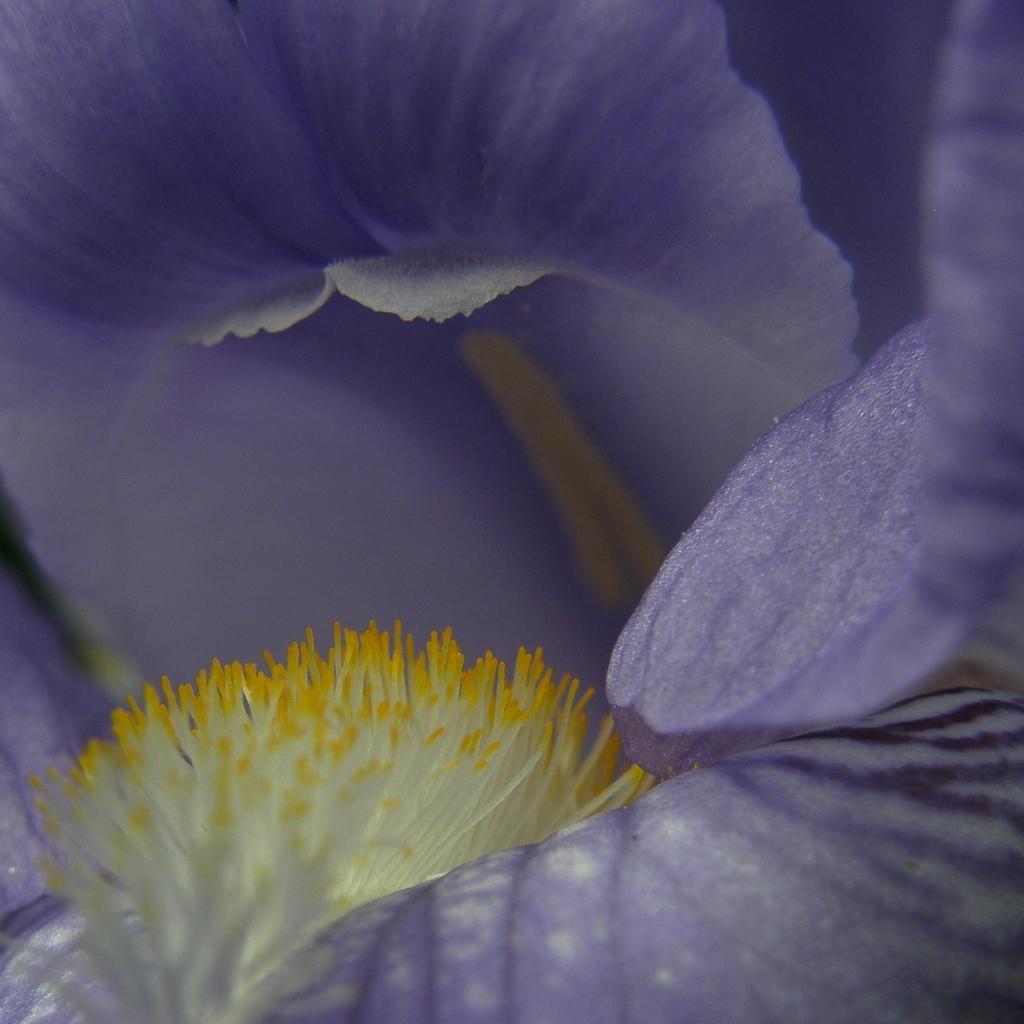Could you give a brief overview of what you see in this image? In this picture we can see flower and petals. In the background of the image it is purple. 